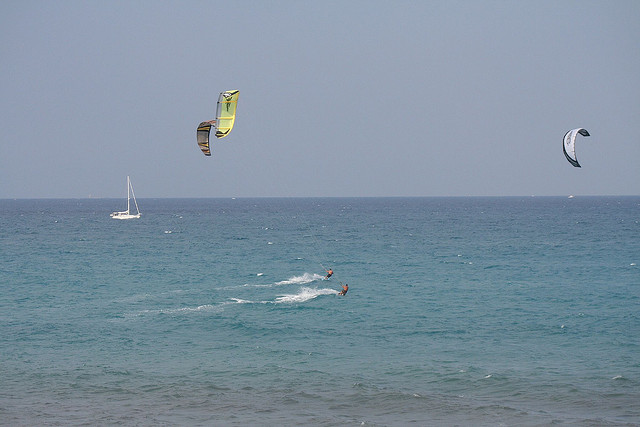What equipment is essential for the sport being performed by the people in the image? The primary equipment for kitesurfing includes a kite which is designed to catch the wind and provide propulsion, a bar which the rider holds onto to control the kite, lines that connect the kite to the bar, and a kitesurf board which the rider stands on. Additionally, the kitesurfer typically wears a harness to attach themselves to the kite, often wears a wetsuit for thermal protection and buoyancy, and may use a helmet and life jacket for safety. In this image, we can see the kites and lines clearly, as well as the board under the feet of the closest kitesurfer. 